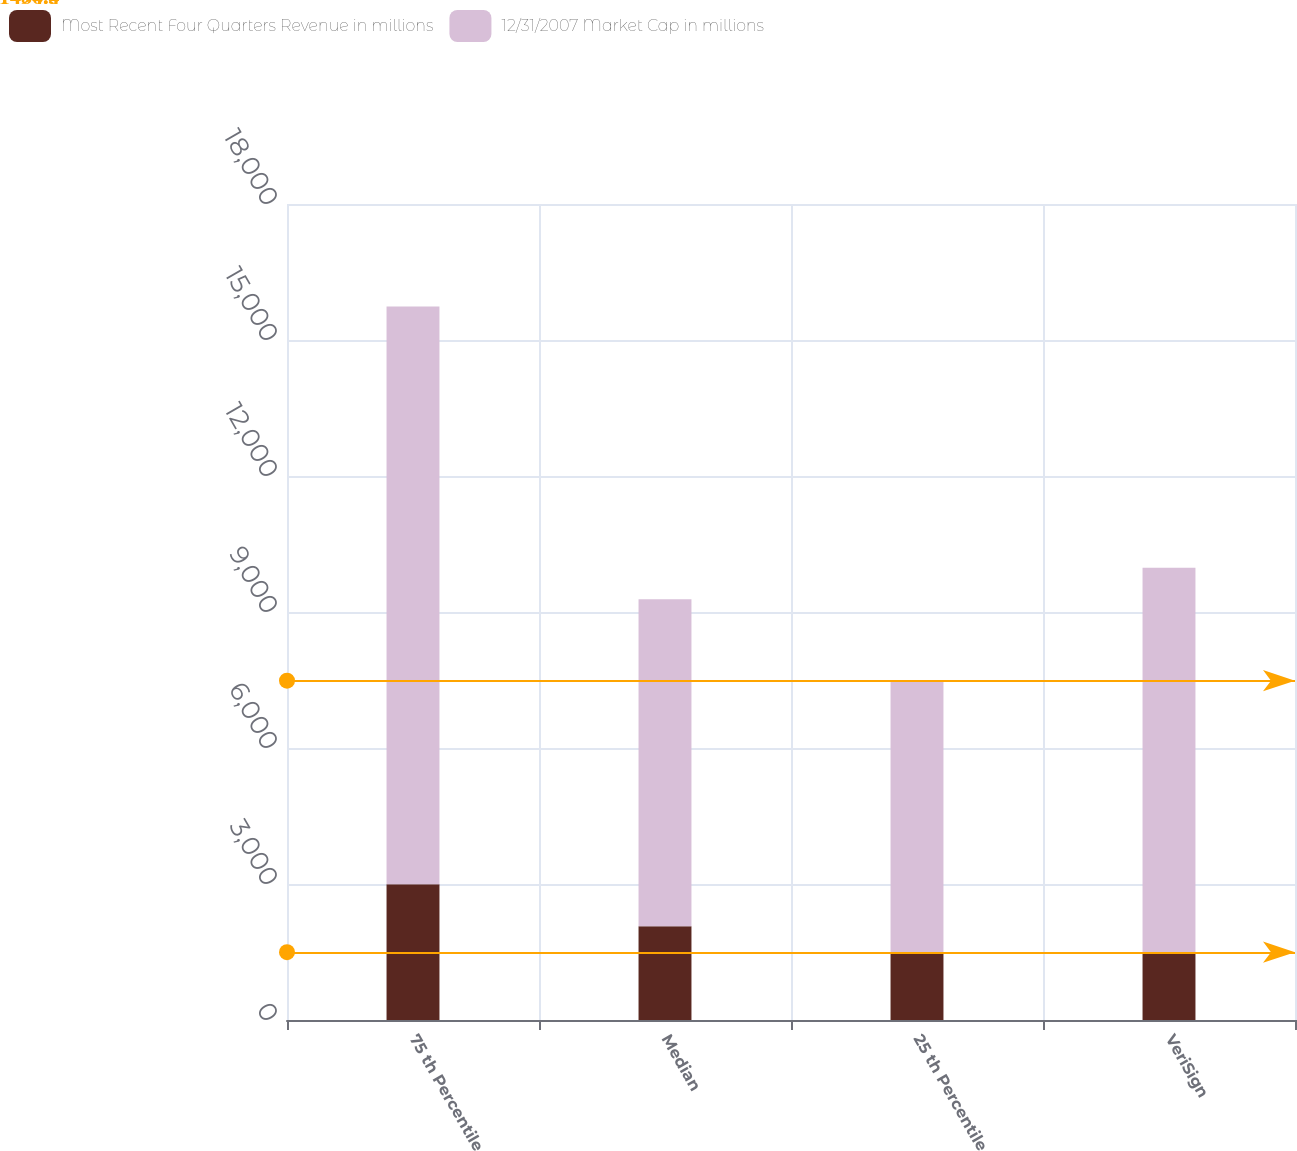<chart> <loc_0><loc_0><loc_500><loc_500><stacked_bar_chart><ecel><fcel>75 th Percentile<fcel>Median<fcel>25 th Percentile<fcel>VeriSign<nl><fcel>Most Recent Four Quarters Revenue in millions<fcel>2997.1<fcel>2070.2<fcel>1498.6<fcel>1496.3<nl><fcel>12/31/2007 Market Cap in millions<fcel>12743.7<fcel>7210.7<fcel>5985.8<fcel>8480.5<nl></chart> 